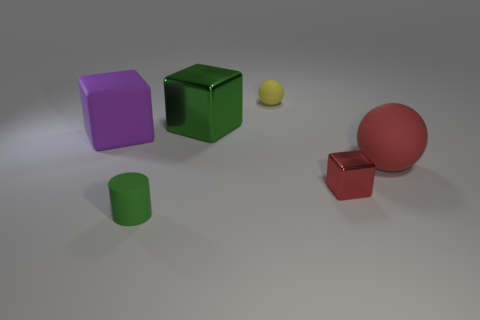Add 3 green metallic cubes. How many objects exist? 9 Subtract all cylinders. How many objects are left? 5 Subtract 1 red balls. How many objects are left? 5 Subtract all large metallic things. Subtract all large metal cubes. How many objects are left? 4 Add 5 cylinders. How many cylinders are left? 6 Add 1 green rubber cubes. How many green rubber cubes exist? 1 